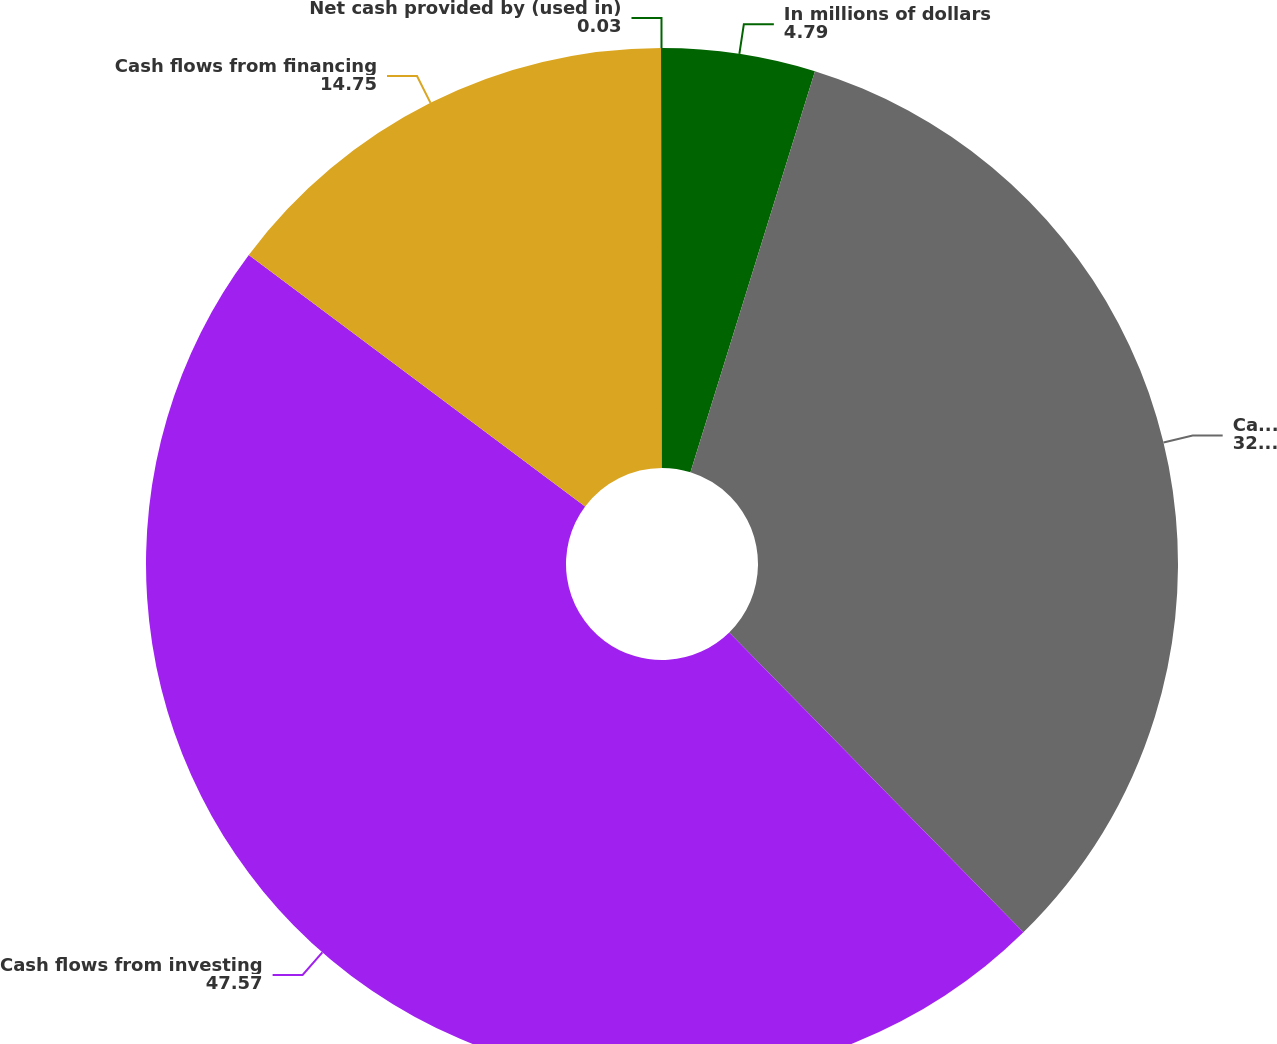<chart> <loc_0><loc_0><loc_500><loc_500><pie_chart><fcel>In millions of dollars<fcel>Cash flows from operating<fcel>Cash flows from investing<fcel>Cash flows from financing<fcel>Net cash provided by (used in)<nl><fcel>4.79%<fcel>32.86%<fcel>47.57%<fcel>14.75%<fcel>0.03%<nl></chart> 